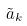Convert formula to latex. <formula><loc_0><loc_0><loc_500><loc_500>\tilde { a } _ { k }</formula> 